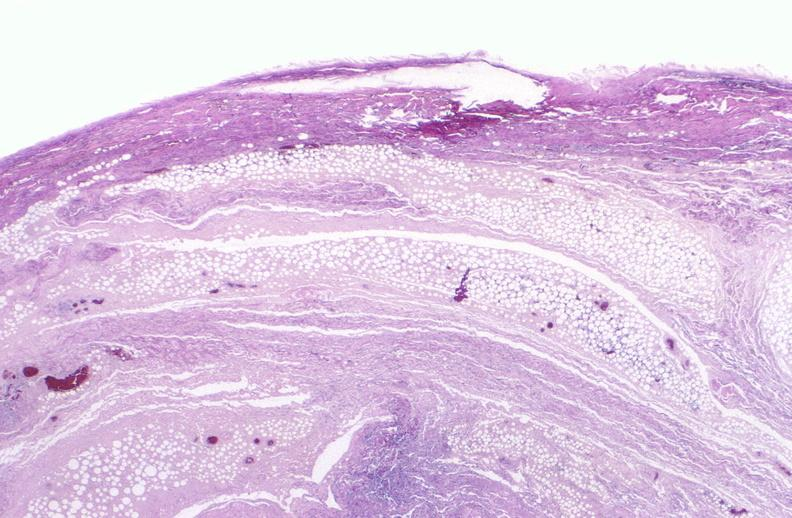what does this image show?
Answer the question using a single word or phrase. Panniculitis and fascitis 